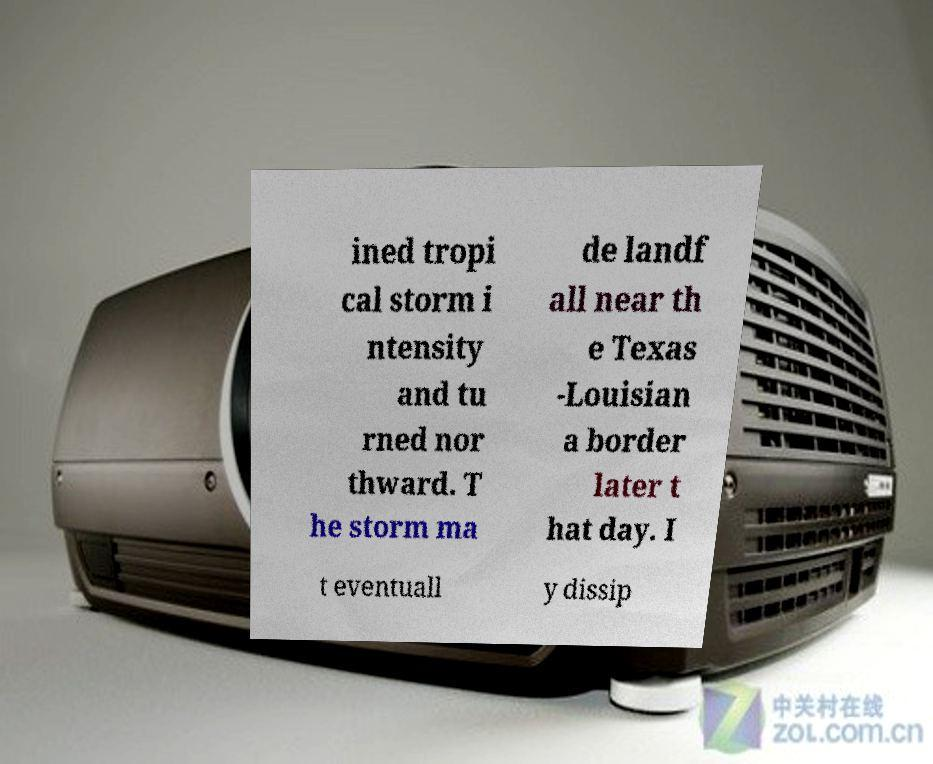Can you read and provide the text displayed in the image?This photo seems to have some interesting text. Can you extract and type it out for me? ined tropi cal storm i ntensity and tu rned nor thward. T he storm ma de landf all near th e Texas -Louisian a border later t hat day. I t eventuall y dissip 